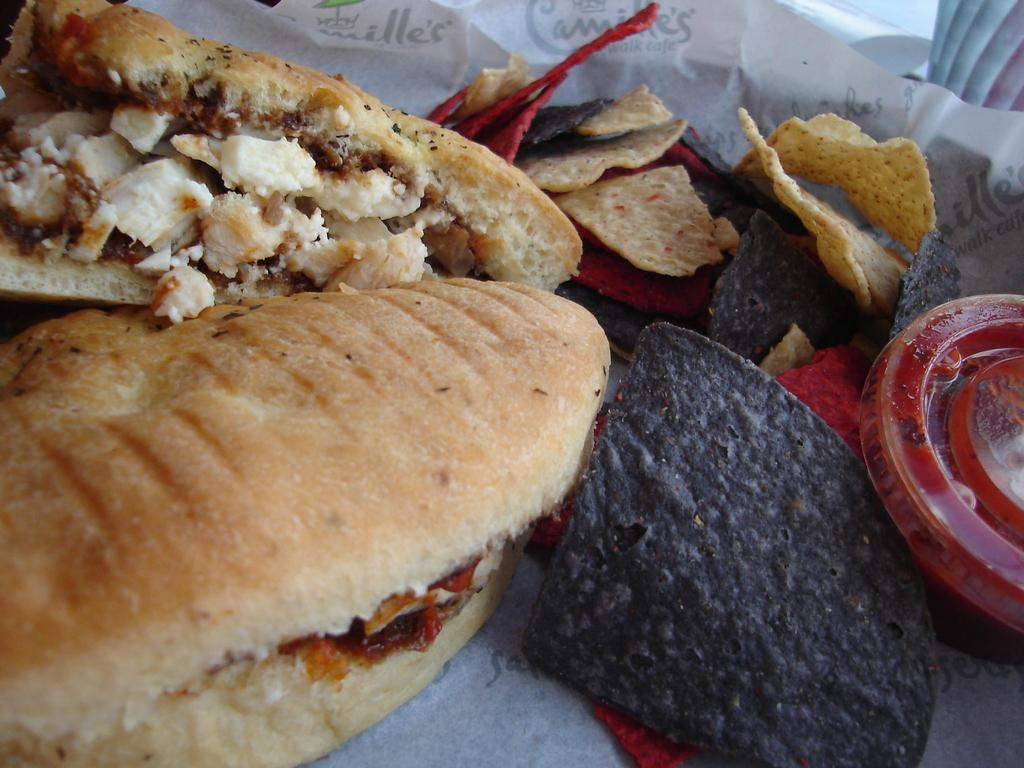What type of food can be seen in the foreground of the image? There are burgers in the foreground of the image. What else is present in the foreground of the image besides the burgers? There are food items and tissue papers in the foreground of the image. What type of ocean can be seen in the background of the image? There is no ocean present in the image; it only features burgers, food items, and tissue papers in the foreground. 